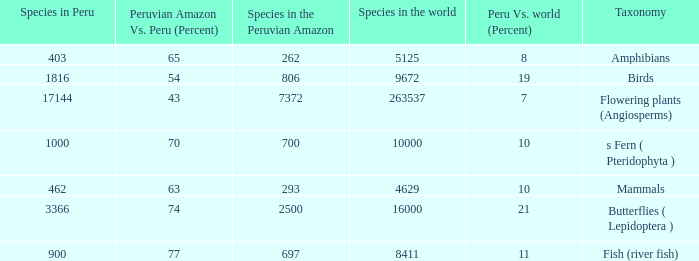What's the maximum peru vs. world (percent) with 9672 species in the world  19.0. 